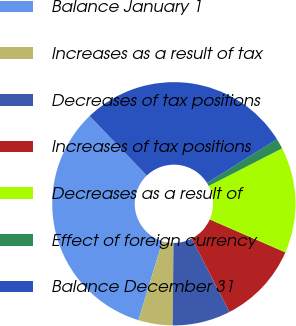Convert chart to OTSL. <chart><loc_0><loc_0><loc_500><loc_500><pie_chart><fcel>Balance January 1<fcel>Increases as a result of tax<fcel>Decreases of tax positions<fcel>Increases of tax positions<fcel>Decreases as a result of<fcel>Effect of foreign currency<fcel>Balance December 31<nl><fcel>33.13%<fcel>4.54%<fcel>7.72%<fcel>10.9%<fcel>14.07%<fcel>1.37%<fcel>28.27%<nl></chart> 